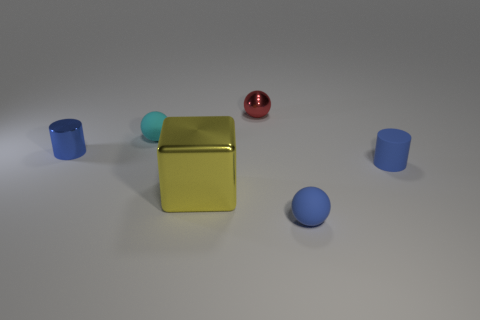Are there any small metal objects that have the same color as the big metallic object?
Offer a terse response. No. Is the material of the yellow thing the same as the small ball that is in front of the small cyan matte sphere?
Your answer should be compact. No. How many tiny objects are blue rubber things or gray shiny cubes?
Give a very brief answer. 2. What material is the tiny ball that is the same color as the rubber cylinder?
Your answer should be compact. Rubber. Are there fewer big red metallic blocks than blue shiny things?
Make the answer very short. Yes. Do the rubber ball behind the yellow block and the blue object that is in front of the yellow thing have the same size?
Your answer should be compact. Yes. How many blue objects are cubes or metallic cylinders?
Ensure brevity in your answer.  1. What is the size of the ball that is the same color as the tiny matte cylinder?
Your response must be concise. Small. Is the number of big purple rubber objects greater than the number of blue metallic cylinders?
Offer a terse response. No. Do the large shiny cube and the small metal cylinder have the same color?
Ensure brevity in your answer.  No. 